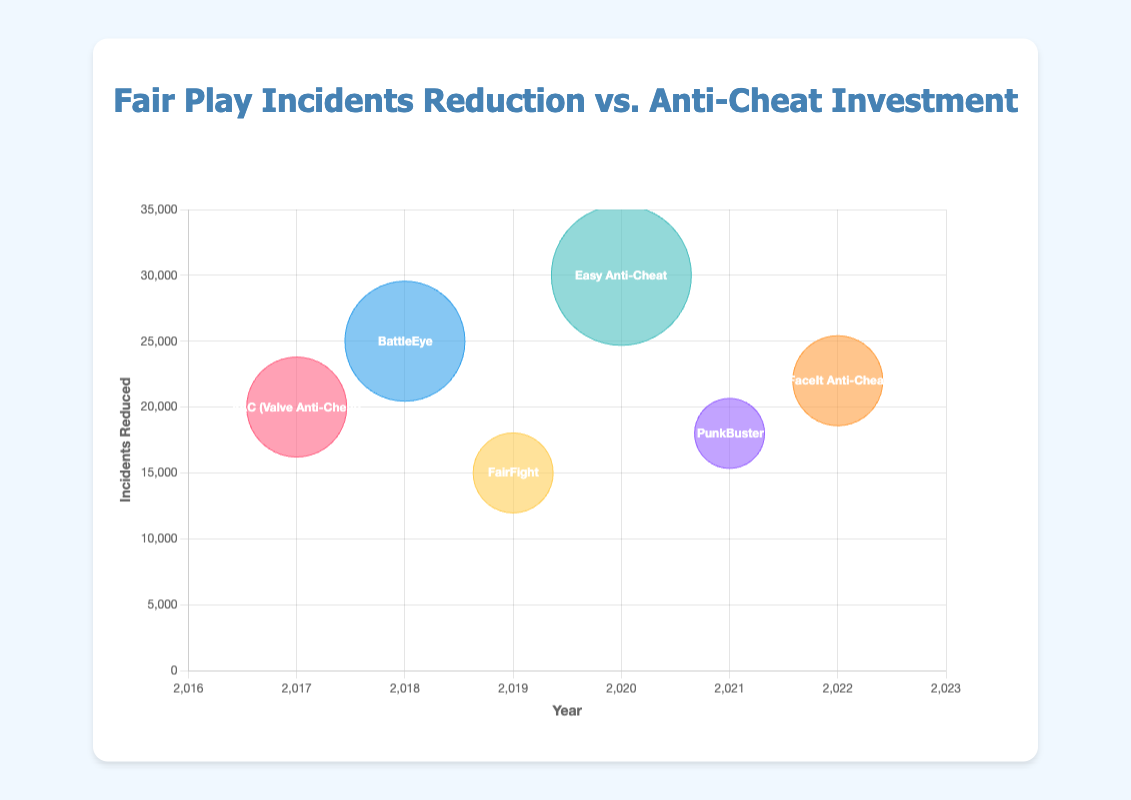what is the total number of anti-cheat measures shown in the figure? Count the number of bubbles on the bubble chart to determine the number of anti-cheat measures.
Answer: 6 Which anti-cheat measure has the highest number of incidents reduced? Look for the tallest bubble along the y-axis. The anti-cheat measure for this bubble is Easy Anti-Cheat with 30,000 incidents reduced in 2020.
Answer: Easy Anti-Cheat How much investment was made for the anti-cheat measure that reduced 25,000 incidents in 2018? Identify the bubble at year 2018 and 25,000 incidents reduced. Check the bubble radius which indicates the investment. Investment for BattleEye was $600,000 in 2018.
Answer: $600,000 What is the trend in incidents reduced from 2017 to 2022? Observe the changes in the height of the bubbles from 2017 to 2022. Notice how the incidents reduced change over the years.
Answer: Upward then fluctuates How does the investment in 2020 compare to the investment in 2019? Look at the bubble sizes for the years 2019 and 2020. The bubble for 2020 is larger, indicating higher investment. 2020 had $700,000 and 2019 had $400,000 investment.
Answer: Higher in 2020 Which year had the lowest number of incidents reduced and what was the anti-cheat measure? Find the shortest bubble along the y-axis which indicates the lowest number of incidents. FairFight in 2019 had the lowest incidents reduced with 15,000.
Answer: 2019, FairFight What is the total investment made across all years shown in the figure? Sum the investments made across each year: $500,000 (2017) + $600,000 (2018) + $400,000 (2019) + $700,000 (2020) + $350,000 (2021) + $450,000 (2022). The total is $3,000,000.
Answer: $3,000,000 Did FaceIt Anti-Cheat reduce more incidents than PunkBuster? Compare the height of the bubbles for FaceIt Anti-Cheat in 2022 and PunkBuster in 2021. FaceIt Anti-Cheat reduced 22,000 incidents whereas PunkBuster reduced 18,000 incidents.
Answer: Yes What is the average number of incidents reduced by all anti-cheat measures over the years? Calculate the sum of incidents reduced and divide by the number of years. Sum is 20000 + 25000 + 15000 + 30000 + 18000 + 22000 = 130000, and there are 6 years, so 130000/6 ≈ 21667.
Answer: 21,667 